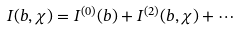Convert formula to latex. <formula><loc_0><loc_0><loc_500><loc_500>I ( b , \chi ) = I ^ { ( 0 ) } ( b ) + I ^ { ( 2 ) } ( b , \chi ) + \cdots</formula> 